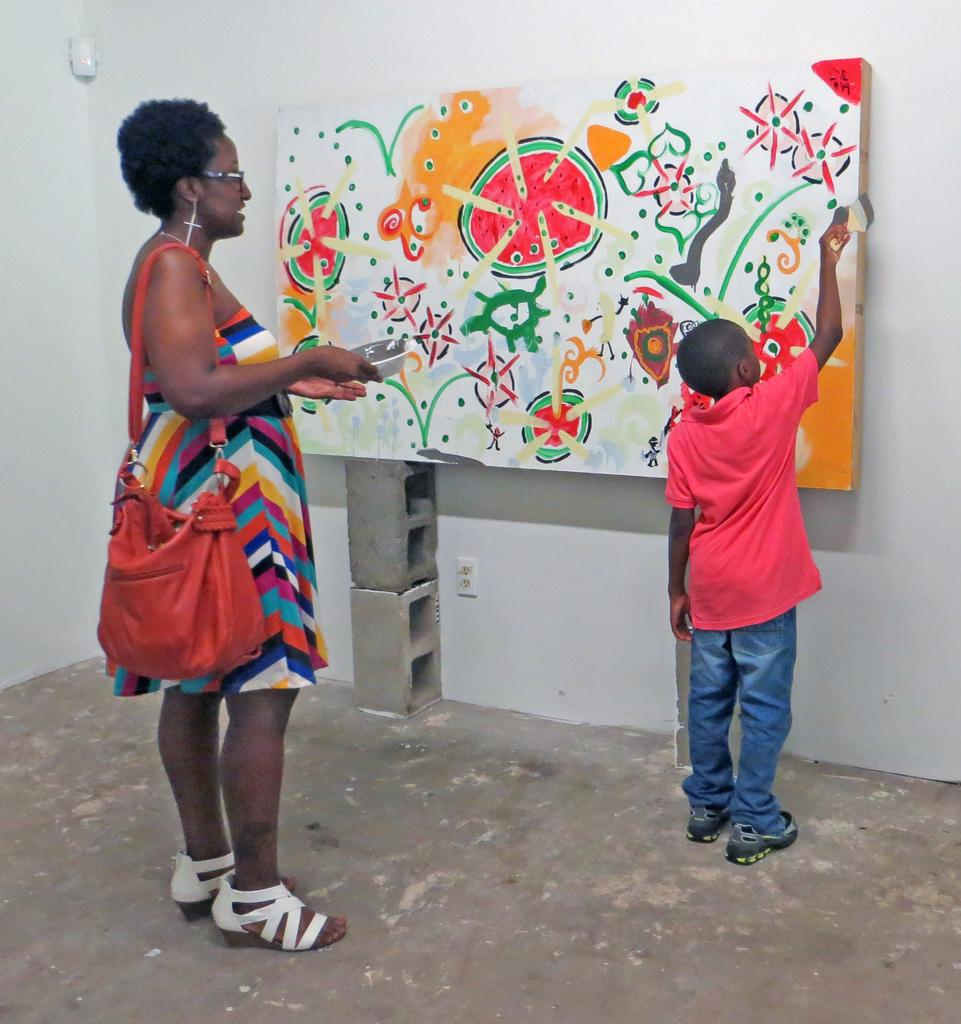Who is the main subject on the left side of the image? There is a lady in the image, and she is standing on the left side. Who is the main subject on the right side of the image? There is a boy in the image, and he is on the right side. What is the boy doing in the image? The boy is painting. What type of meat is the deer eating in the image? There is no deer or meat present in the image. How many toes can be seen on the lady's feet in the image? The image does not show the lady's feet, so the number of toes cannot be determined. 